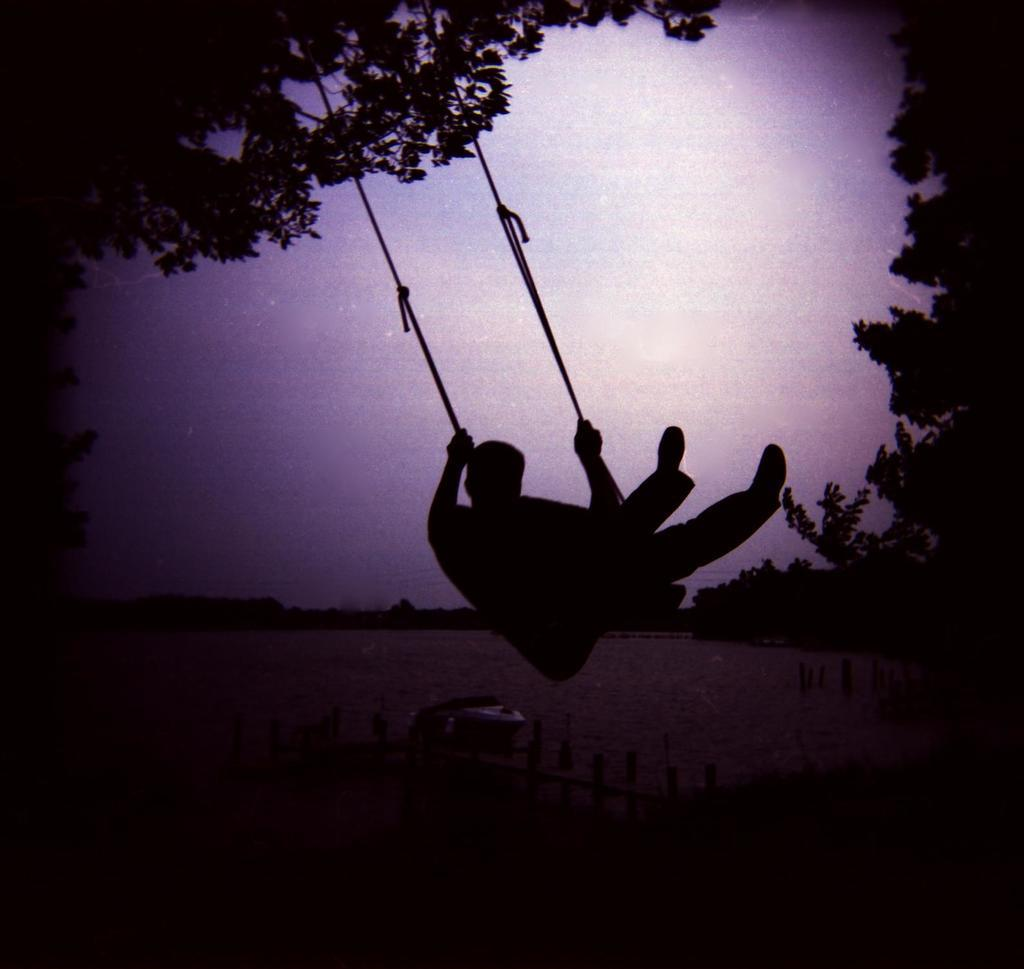What is the main subject of the image? There is a person on a swing in the image. What can be seen below the swing? The ground is visible next to the swing. What is near the swing to provide support or safety? There is railing near the swing. What type of natural environment is visible in the background of the image? There are trees in the background of the image. What is visible above the trees in the background? The sky is visible in the background of the image. How many men are seen answering questions in the image? There are no men answering questions in the image; it features a person on a swing with a background of trees and the sky. 